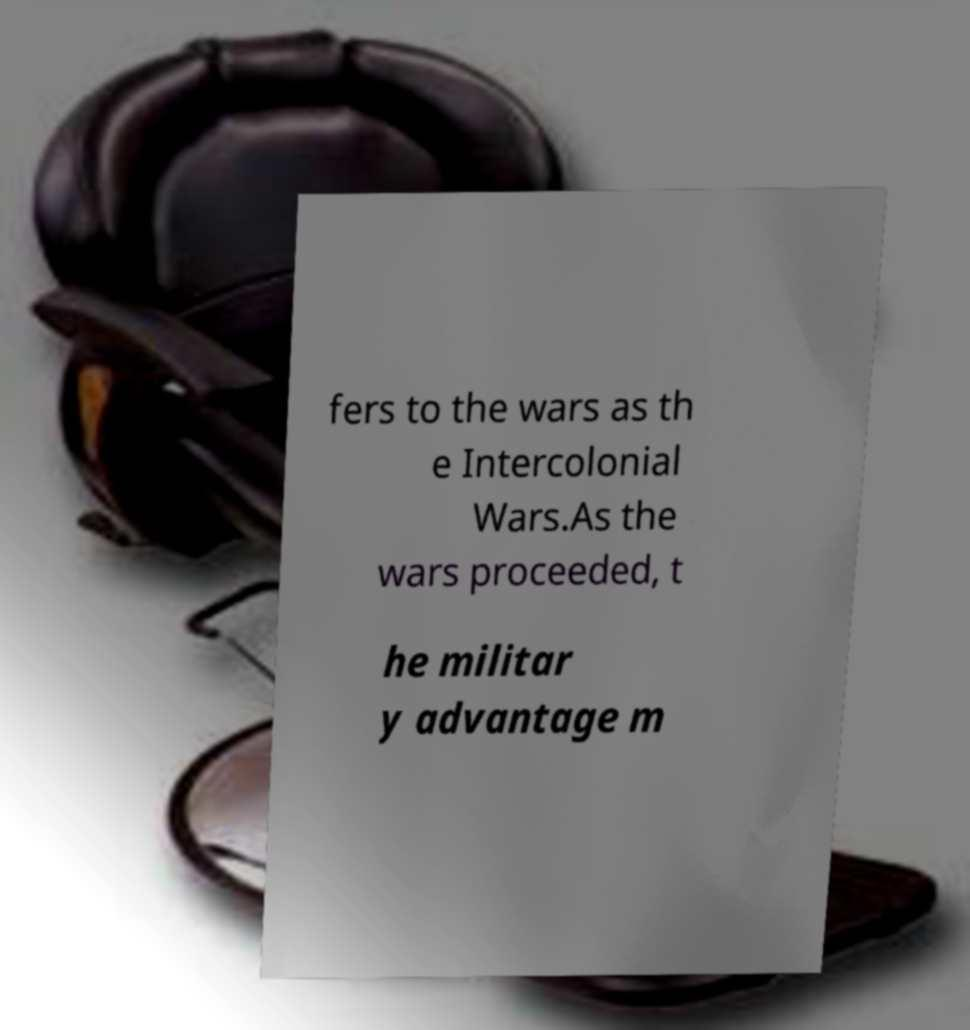Can you read and provide the text displayed in the image?This photo seems to have some interesting text. Can you extract and type it out for me? fers to the wars as th e Intercolonial Wars.As the wars proceeded, t he militar y advantage m 